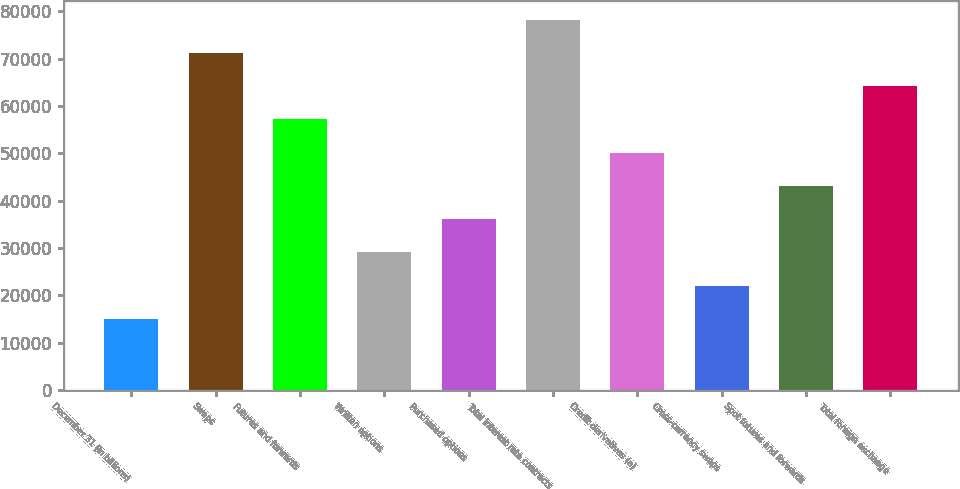<chart> <loc_0><loc_0><loc_500><loc_500><bar_chart><fcel>December 31 (in billions)<fcel>Swaps<fcel>Futures and forwards<fcel>Written options<fcel>Purchased options<fcel>Total interest rate contracts<fcel>Credit derivatives (a)<fcel>Cross-currency swaps<fcel>Spot futures and forwards<fcel>Total foreign exchange<nl><fcel>15048.8<fcel>71156<fcel>57129.2<fcel>29075.6<fcel>36089<fcel>78169.4<fcel>50115.8<fcel>22062.2<fcel>43102.4<fcel>64142.6<nl></chart> 